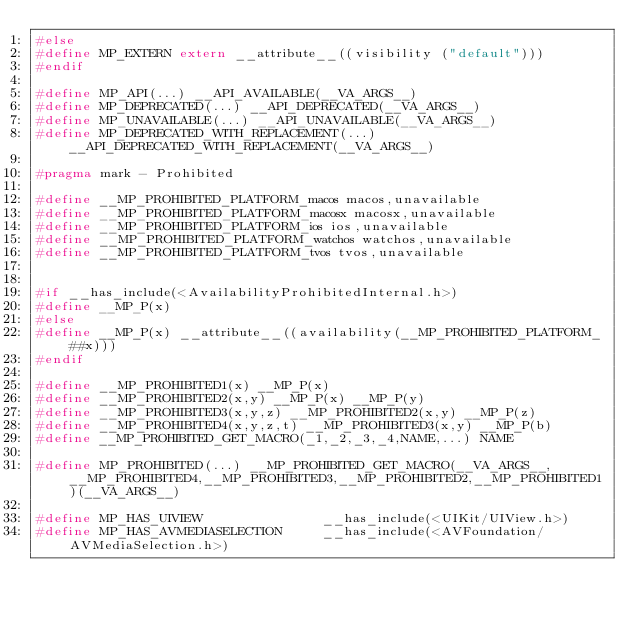Convert code to text. <code><loc_0><loc_0><loc_500><loc_500><_C_>#else
#define MP_EXTERN extern __attribute__((visibility ("default")))
#endif

#define MP_API(...) __API_AVAILABLE(__VA_ARGS__)
#define MP_DEPRECATED(...) __API_DEPRECATED(__VA_ARGS__)
#define MP_UNAVAILABLE(...) __API_UNAVAILABLE(__VA_ARGS__)
#define MP_DEPRECATED_WITH_REPLACEMENT(...) __API_DEPRECATED_WITH_REPLACEMENT(__VA_ARGS__)

#pragma mark - Prohibited

#define __MP_PROHIBITED_PLATFORM_macos macos,unavailable
#define __MP_PROHIBITED_PLATFORM_macosx macosx,unavailable
#define __MP_PROHIBITED_PLATFORM_ios ios,unavailable
#define __MP_PROHIBITED_PLATFORM_watchos watchos,unavailable
#define __MP_PROHIBITED_PLATFORM_tvos tvos,unavailable


#if __has_include(<AvailabilityProhibitedInternal.h>)
#define __MP_P(x)
#else
#define __MP_P(x) __attribute__((availability(__MP_PROHIBITED_PLATFORM_##x)))
#endif

#define __MP_PROHIBITED1(x) __MP_P(x)
#define __MP_PROHIBITED2(x,y) __MP_P(x) __MP_P(y)
#define __MP_PROHIBITED3(x,y,z) __MP_PROHIBITED2(x,y) __MP_P(z)
#define __MP_PROHIBITED4(x,y,z,t) __MP_PROHIBITED3(x,y) __MP_P(b)
#define __MP_PROHIBITED_GET_MACRO(_1,_2,_3,_4,NAME,...) NAME

#define MP_PROHIBITED(...) __MP_PROHIBITED_GET_MACRO(__VA_ARGS__,__MP_PROHIBITED4,__MP_PROHIBITED3,__MP_PROHIBITED2,__MP_PROHIBITED1)(__VA_ARGS__)

#define MP_HAS_UIVIEW               __has_include(<UIKit/UIView.h>)
#define MP_HAS_AVMEDIASELECTION     __has_include(<AVFoundation/AVMediaSelection.h>)
</code> 